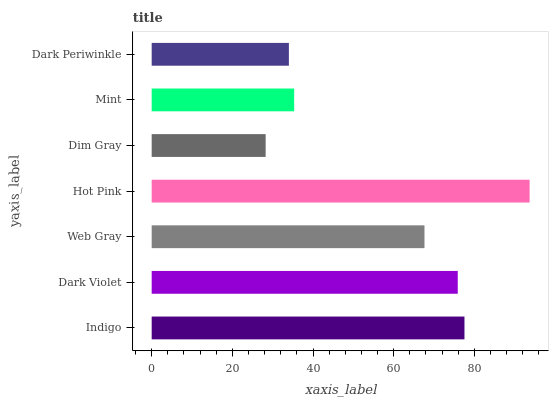Is Dim Gray the minimum?
Answer yes or no. Yes. Is Hot Pink the maximum?
Answer yes or no. Yes. Is Dark Violet the minimum?
Answer yes or no. No. Is Dark Violet the maximum?
Answer yes or no. No. Is Indigo greater than Dark Violet?
Answer yes or no. Yes. Is Dark Violet less than Indigo?
Answer yes or no. Yes. Is Dark Violet greater than Indigo?
Answer yes or no. No. Is Indigo less than Dark Violet?
Answer yes or no. No. Is Web Gray the high median?
Answer yes or no. Yes. Is Web Gray the low median?
Answer yes or no. Yes. Is Dim Gray the high median?
Answer yes or no. No. Is Mint the low median?
Answer yes or no. No. 